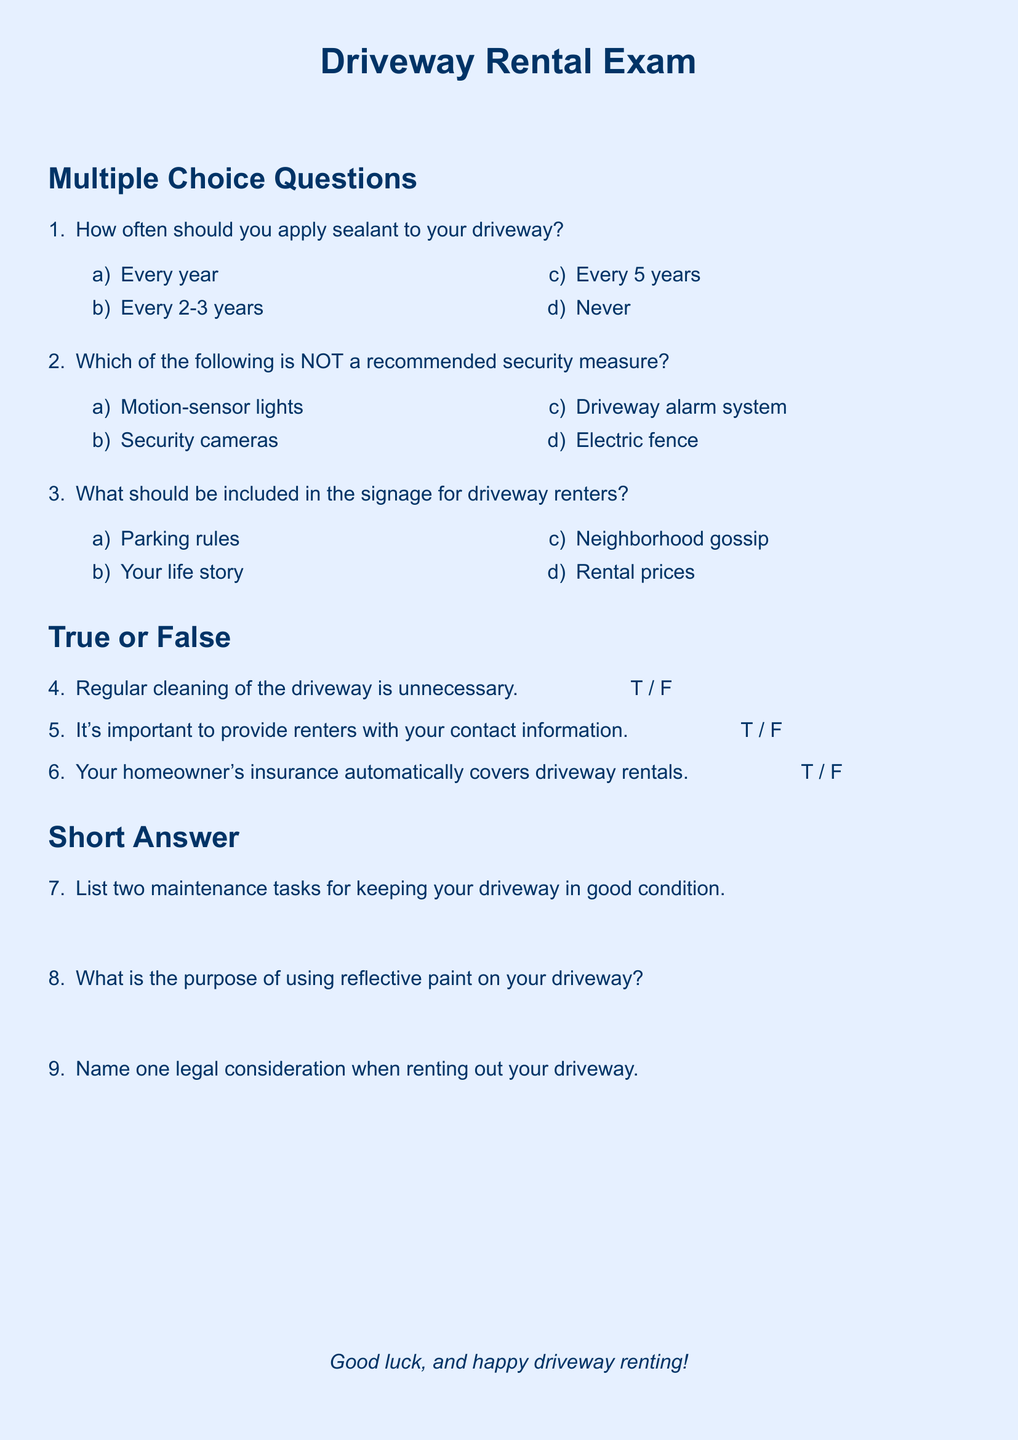How often should sealant be applied? The recommended frequency of applying sealant is mentioned in the multiple-choice section, one of the options is "Every 2-3 years."
Answer: Every 2-3 years What is NOT a recommended security measure? The document lists options for security measures in multiple-choice format, and the correct answer is the one that does not belong to the recommended list.
Answer: Electric fence What should be included in the signage for driveway renters? The multiple-choice question specifies that one of the options relates to what should be included in the signage, which is "Parking rules."
Answer: Parking rules Is regular cleaning of the driveway necessary? The true or false question asks about the necessity of regular cleaning, which must be answered based on the context of the document.
Answer: False What is important to provide renters? The text emphasizes the importance of providing renters with specific information, which is described in the true or false section.
Answer: Contact information 